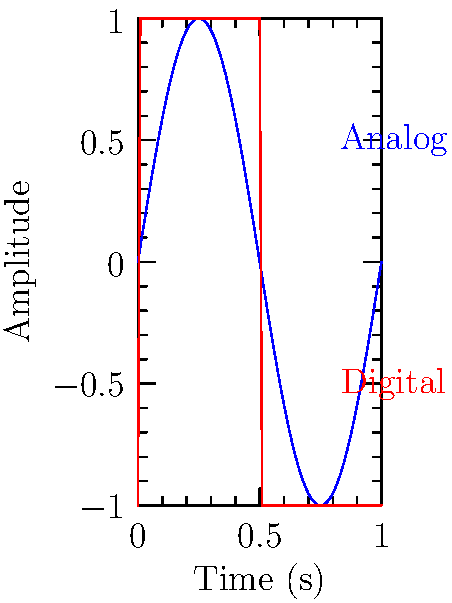As a label executive negotiating licensing agreements for DJ remixes, you need to understand digital audio basics. The graph shows an analog sine wave (blue) and its digital representation (red). If the digital signal has 8 samples per cycle, what is the minimum sampling rate required to accurately capture a 22 kHz tone in the remix? To determine the minimum sampling rate, we need to follow these steps:

1. Recall the Nyquist-Shannon sampling theorem: The sampling rate must be at least twice the highest frequency in the signal to avoid aliasing.

2. The highest frequency in our signal is 22 kHz.

3. Therefore, the minimum sampling rate according to Nyquist-Shannon would be:
   $f_s = 2 \times 22\text{ kHz} = 44\text{ kHz}$

4. However, the question states that the digital signal has 8 samples per cycle. This means we need to sample 8 times faster than the Nyquist rate.

5. Calculate the actual required sampling rate:
   $f_{\text{actual}} = 8 \times 44\text{ kHz} = 352\text{ kHz}$

Thus, to accurately capture a 22 kHz tone with 8 samples per cycle, we need a sampling rate of 352 kHz.
Answer: 352 kHz 